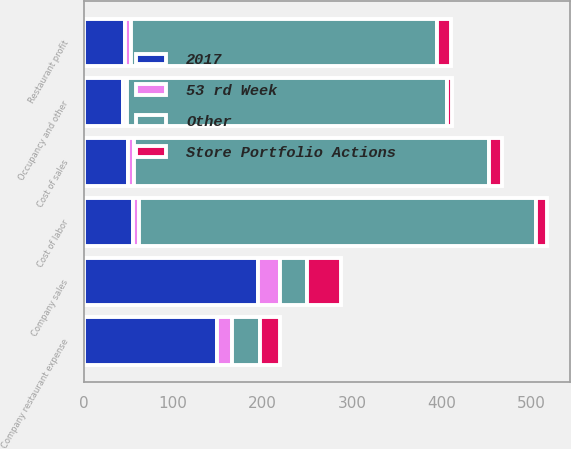Convert chart. <chart><loc_0><loc_0><loc_500><loc_500><stacked_bar_chart><ecel><fcel>Company sales<fcel>Cost of sales<fcel>Cost of labor<fcel>Occupancy and other<fcel>Company restaurant expense<fcel>Restaurant profit<nl><fcel>Other<fcel>31<fcel>397<fcel>443<fcel>358<fcel>31<fcel>342<nl><fcel>2017<fcel>195<fcel>50<fcel>55<fcel>44<fcel>149<fcel>46<nl><fcel>Store Portfolio Actions<fcel>38<fcel>15<fcel>13<fcel>6<fcel>22<fcel>16<nl><fcel>53 rd Week<fcel>24<fcel>6<fcel>7<fcel>4<fcel>17<fcel>7<nl></chart> 